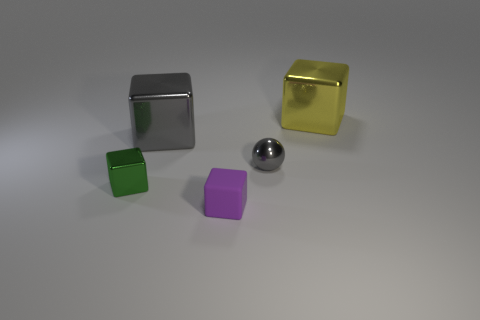Subtract all red blocks. Subtract all green cylinders. How many blocks are left? 4 Add 3 small matte objects. How many objects exist? 8 Subtract all spheres. How many objects are left? 4 Add 1 big gray metallic blocks. How many big gray metallic blocks are left? 2 Add 1 large yellow metallic blocks. How many large yellow metallic blocks exist? 2 Subtract 1 gray blocks. How many objects are left? 4 Subtract all small red rubber objects. Subtract all gray objects. How many objects are left? 3 